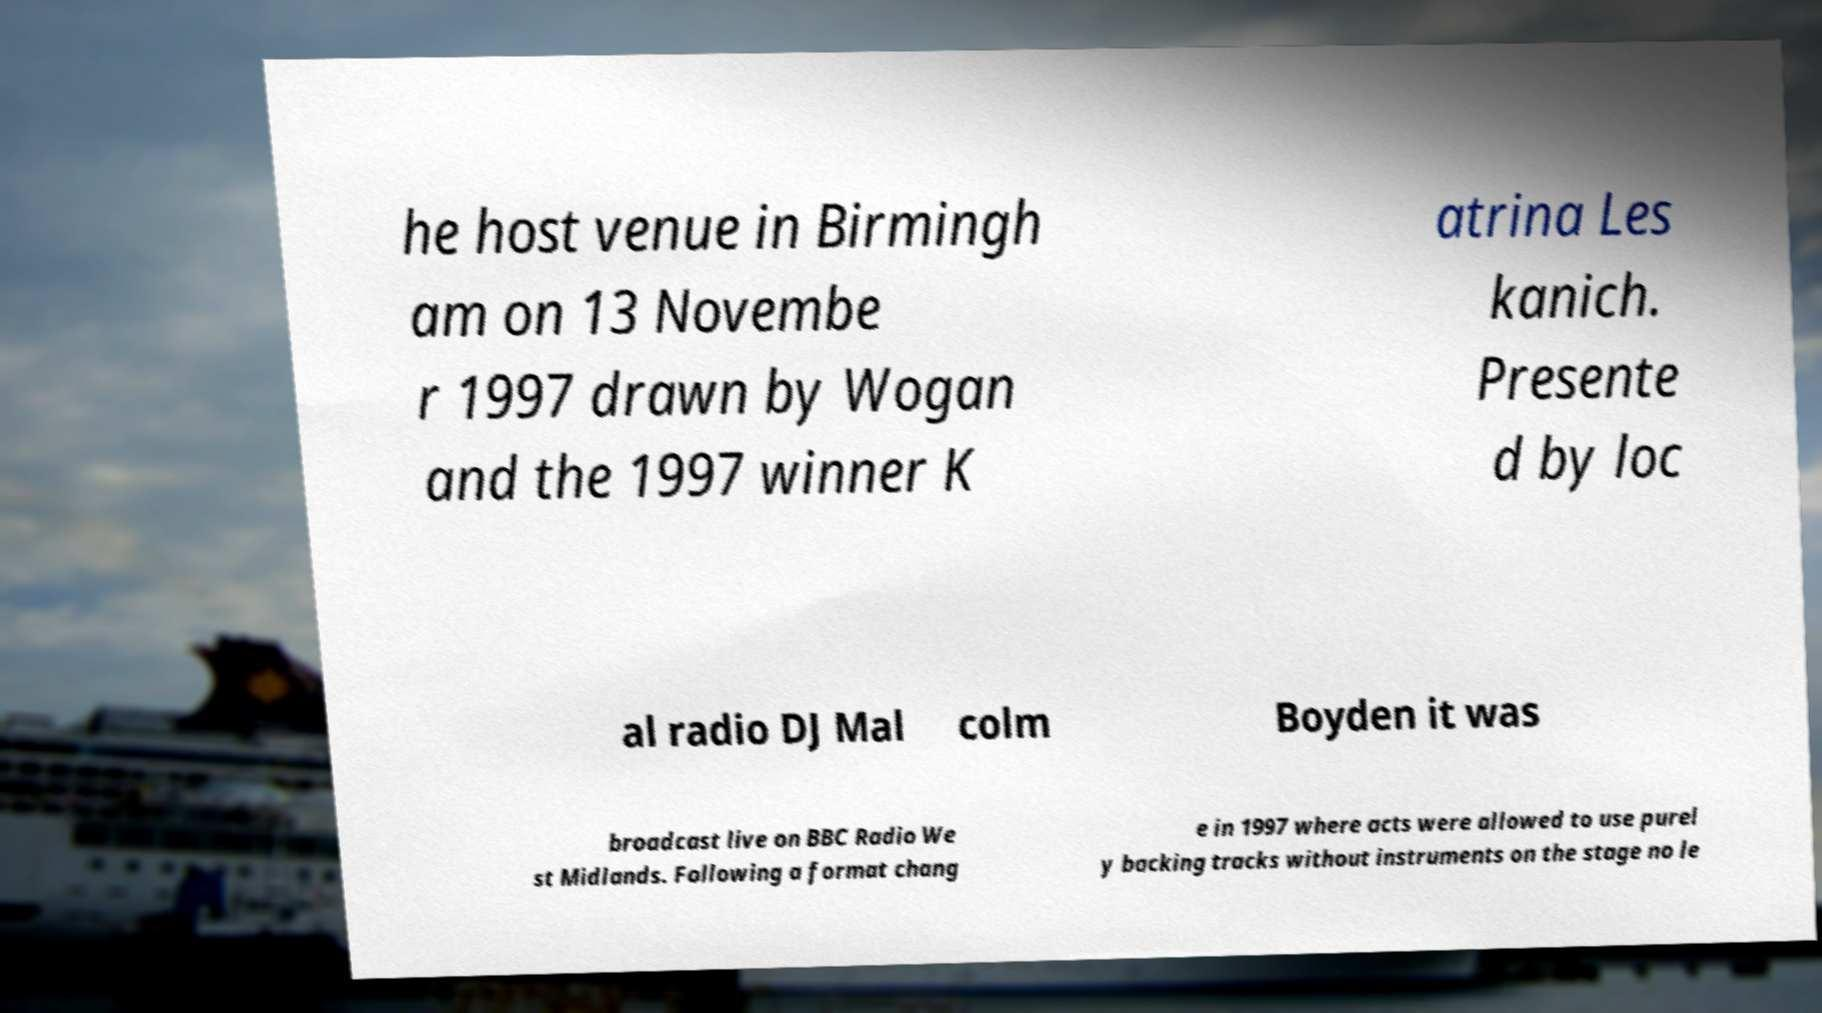Could you assist in decoding the text presented in this image and type it out clearly? he host venue in Birmingh am on 13 Novembe r 1997 drawn by Wogan and the 1997 winner K atrina Les kanich. Presente d by loc al radio DJ Mal colm Boyden it was broadcast live on BBC Radio We st Midlands. Following a format chang e in 1997 where acts were allowed to use purel y backing tracks without instruments on the stage no le 